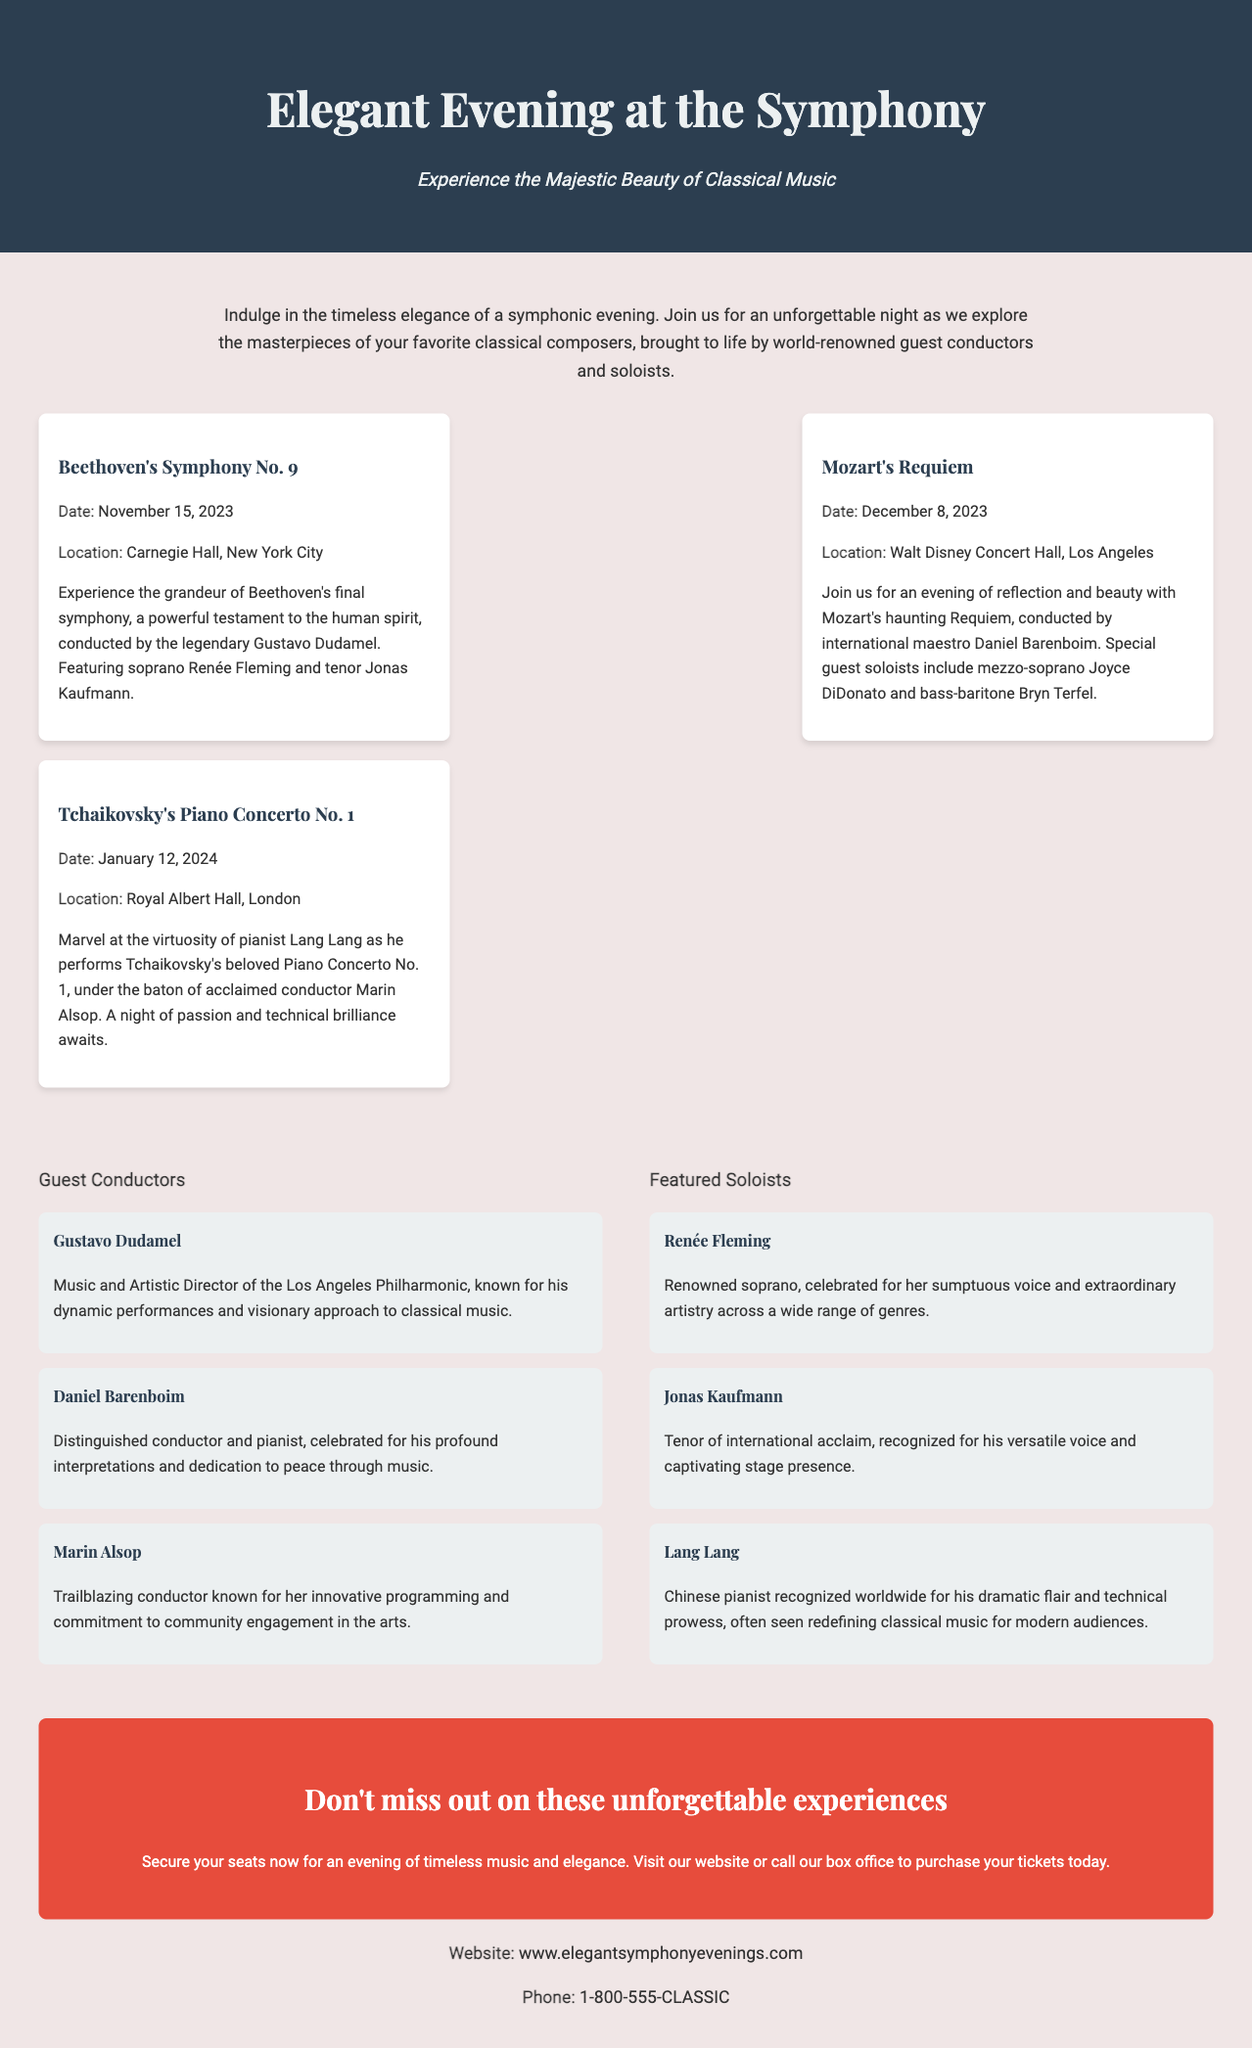What is the title of the advertisement? The title of the advertisement is presented prominently at the top of the document.
Answer: Elegant Evening at the Symphony When is Beethoven's Symphony No. 9 scheduled? The date for Beethoven's Symphony No. 9 is mentioned clearly in the concert card for that performance.
Answer: November 15, 2023 Where will Mozart's Requiem be held? The location is specified in the concert card for Mozart's Requiem performance.
Answer: Walt Disney Concert Hall, Los Angeles Who is the pianist performing Tchaikovsky's Piano Concerto No. 1? The concert card for Tchaikovsky's Piano Concerto No. 1 lists the featured pianist.
Answer: Lang Lang What type of music is featured in this advertisement? The document emphasizes a specific genre that relates to the performances it describes.
Answer: Classical music Who is the guest conductor for Beethoven's Symphony No. 9? The concert card for Beethoven's Symphony No. 9 provides the name of the guest conductor.
Answer: Gustavo Dudamel What is the call to action in the advertisement? The call to action encourages a specific action from potential audience members detailed towards the end of the document.
Answer: Secure your seats now What is the contact phone number provided? The contact information section includes a specific phone number to reach the box office.
Answer: 1-800-555-CLASSIC 